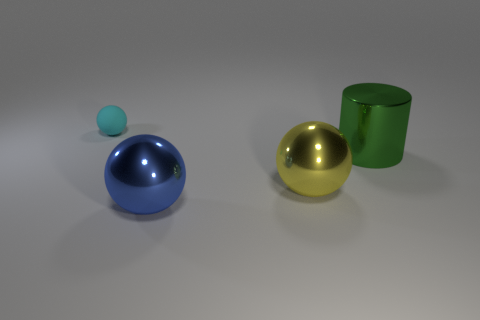Are there any other things that have the same material as the cyan object?
Make the answer very short. No. Is the color of the cylinder the same as the small matte ball?
Provide a short and direct response. No. Are there fewer green metallic cylinders right of the yellow sphere than large green metal cylinders to the left of the cyan rubber ball?
Your response must be concise. No. What color is the tiny rubber ball?
Your answer should be compact. Cyan. What number of objects have the same color as the tiny sphere?
Offer a very short reply. 0. Are there any big green cylinders right of the big metal cylinder?
Your answer should be very brief. No. Is the number of tiny objects that are in front of the large yellow object the same as the number of big blue metallic spheres that are behind the tiny cyan matte object?
Your answer should be very brief. Yes. There is a metallic sphere on the right side of the large blue metallic ball; is its size the same as the ball in front of the yellow shiny ball?
Offer a very short reply. Yes. There is a thing that is on the left side of the metallic object that is in front of the big sphere on the right side of the large blue ball; what is its shape?
Provide a short and direct response. Sphere. What size is the yellow thing that is the same shape as the tiny cyan object?
Your answer should be compact. Large. 